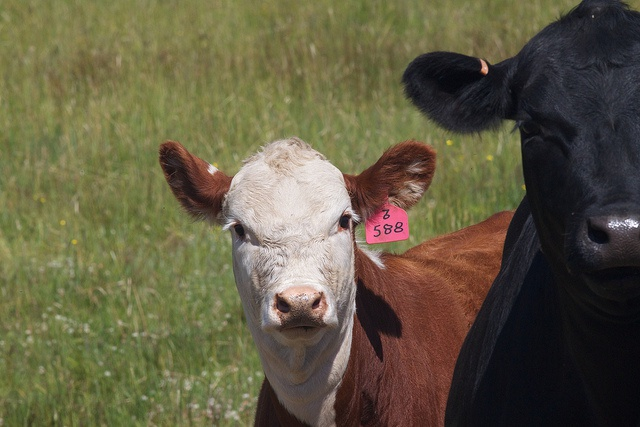Describe the objects in this image and their specific colors. I can see cow in olive, black, and gray tones and cow in olive, maroon, lightgray, gray, and black tones in this image. 